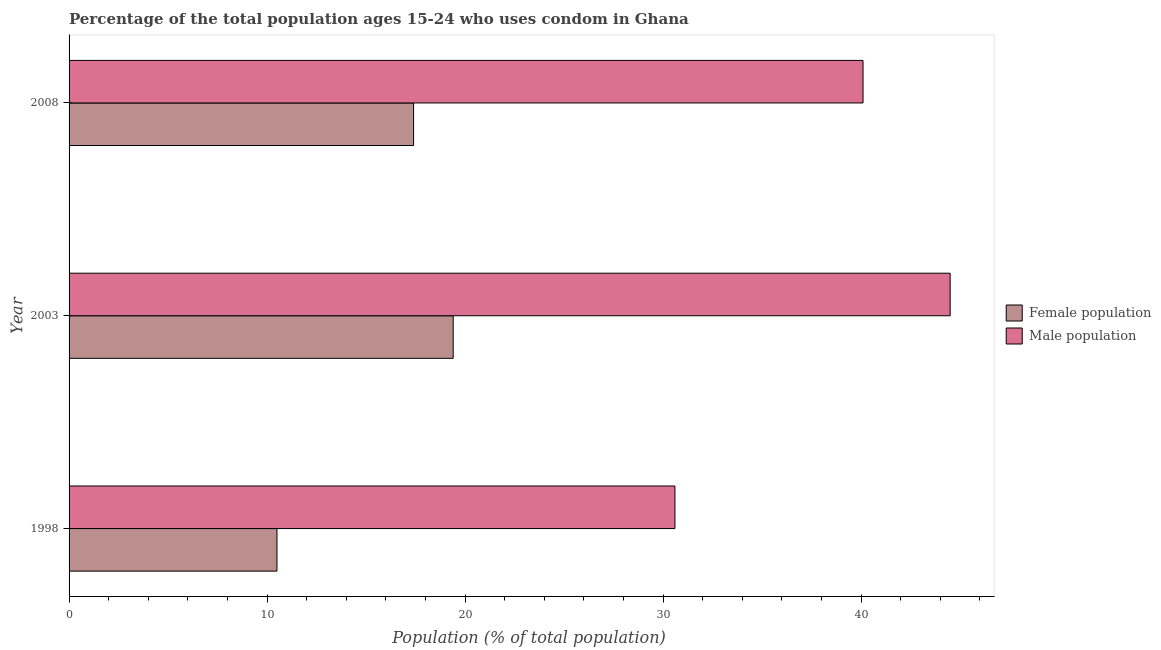How many different coloured bars are there?
Your response must be concise. 2. How many bars are there on the 2nd tick from the bottom?
Provide a succinct answer. 2. Across all years, what is the maximum male population?
Your response must be concise. 44.5. Across all years, what is the minimum male population?
Offer a very short reply. 30.6. In which year was the male population minimum?
Your response must be concise. 1998. What is the total female population in the graph?
Ensure brevity in your answer.  47.3. What is the difference between the male population in 2003 and the female population in 2008?
Keep it short and to the point. 27.1. What is the average male population per year?
Offer a very short reply. 38.4. In the year 1998, what is the difference between the female population and male population?
Your answer should be very brief. -20.1. What is the ratio of the male population in 1998 to that in 2003?
Provide a short and direct response. 0.69. What is the difference between the highest and the second highest female population?
Keep it short and to the point. 2. In how many years, is the female population greater than the average female population taken over all years?
Provide a short and direct response. 2. Is the sum of the female population in 2003 and 2008 greater than the maximum male population across all years?
Give a very brief answer. No. What does the 2nd bar from the top in 2008 represents?
Give a very brief answer. Female population. What does the 2nd bar from the bottom in 1998 represents?
Give a very brief answer. Male population. Are the values on the major ticks of X-axis written in scientific E-notation?
Keep it short and to the point. No. Does the graph contain grids?
Make the answer very short. No. Where does the legend appear in the graph?
Your answer should be very brief. Center right. How many legend labels are there?
Offer a terse response. 2. What is the title of the graph?
Provide a short and direct response. Percentage of the total population ages 15-24 who uses condom in Ghana. Does "From Government" appear as one of the legend labels in the graph?
Provide a succinct answer. No. What is the label or title of the X-axis?
Give a very brief answer. Population (% of total population) . What is the Population (% of total population)  in Male population in 1998?
Make the answer very short. 30.6. What is the Population (% of total population)  in Female population in 2003?
Your answer should be very brief. 19.4. What is the Population (% of total population)  of Male population in 2003?
Provide a succinct answer. 44.5. What is the Population (% of total population)  in Male population in 2008?
Your answer should be compact. 40.1. Across all years, what is the maximum Population (% of total population)  in Male population?
Offer a very short reply. 44.5. Across all years, what is the minimum Population (% of total population)  in Male population?
Your answer should be compact. 30.6. What is the total Population (% of total population)  of Female population in the graph?
Make the answer very short. 47.3. What is the total Population (% of total population)  in Male population in the graph?
Provide a short and direct response. 115.2. What is the difference between the Population (% of total population)  of Female population in 2003 and that in 2008?
Make the answer very short. 2. What is the difference between the Population (% of total population)  of Female population in 1998 and the Population (% of total population)  of Male population in 2003?
Make the answer very short. -34. What is the difference between the Population (% of total population)  of Female population in 1998 and the Population (% of total population)  of Male population in 2008?
Your response must be concise. -29.6. What is the difference between the Population (% of total population)  in Female population in 2003 and the Population (% of total population)  in Male population in 2008?
Make the answer very short. -20.7. What is the average Population (% of total population)  in Female population per year?
Your answer should be compact. 15.77. What is the average Population (% of total population)  of Male population per year?
Your answer should be compact. 38.4. In the year 1998, what is the difference between the Population (% of total population)  of Female population and Population (% of total population)  of Male population?
Your answer should be compact. -20.1. In the year 2003, what is the difference between the Population (% of total population)  in Female population and Population (% of total population)  in Male population?
Keep it short and to the point. -25.1. In the year 2008, what is the difference between the Population (% of total population)  in Female population and Population (% of total population)  in Male population?
Your answer should be compact. -22.7. What is the ratio of the Population (% of total population)  in Female population in 1998 to that in 2003?
Offer a terse response. 0.54. What is the ratio of the Population (% of total population)  of Male population in 1998 to that in 2003?
Make the answer very short. 0.69. What is the ratio of the Population (% of total population)  in Female population in 1998 to that in 2008?
Make the answer very short. 0.6. What is the ratio of the Population (% of total population)  of Male population in 1998 to that in 2008?
Your answer should be very brief. 0.76. What is the ratio of the Population (% of total population)  of Female population in 2003 to that in 2008?
Your answer should be compact. 1.11. What is the ratio of the Population (% of total population)  in Male population in 2003 to that in 2008?
Offer a terse response. 1.11. What is the difference between the highest and the second highest Population (% of total population)  of Female population?
Provide a short and direct response. 2. What is the difference between the highest and the second highest Population (% of total population)  of Male population?
Offer a terse response. 4.4. What is the difference between the highest and the lowest Population (% of total population)  of Female population?
Keep it short and to the point. 8.9. 